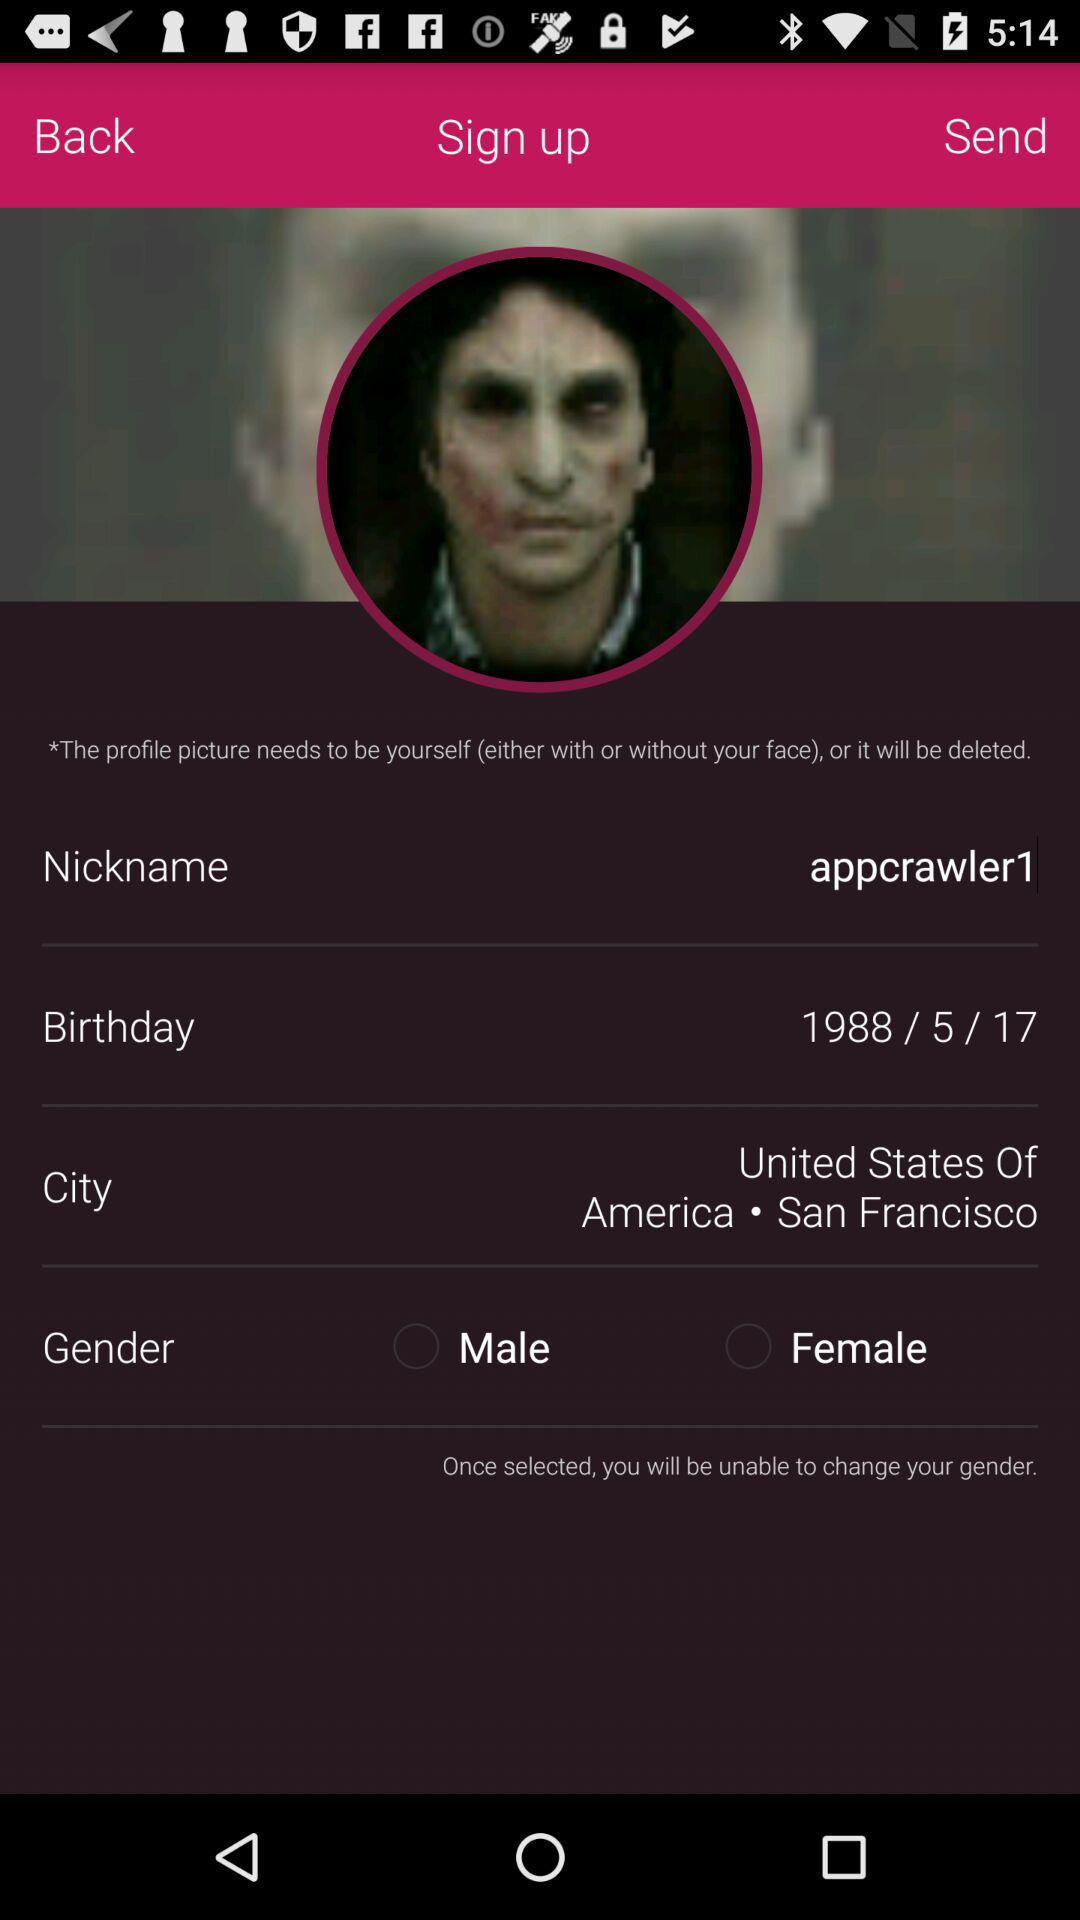What is the selected city? The city is "San Francisco". 